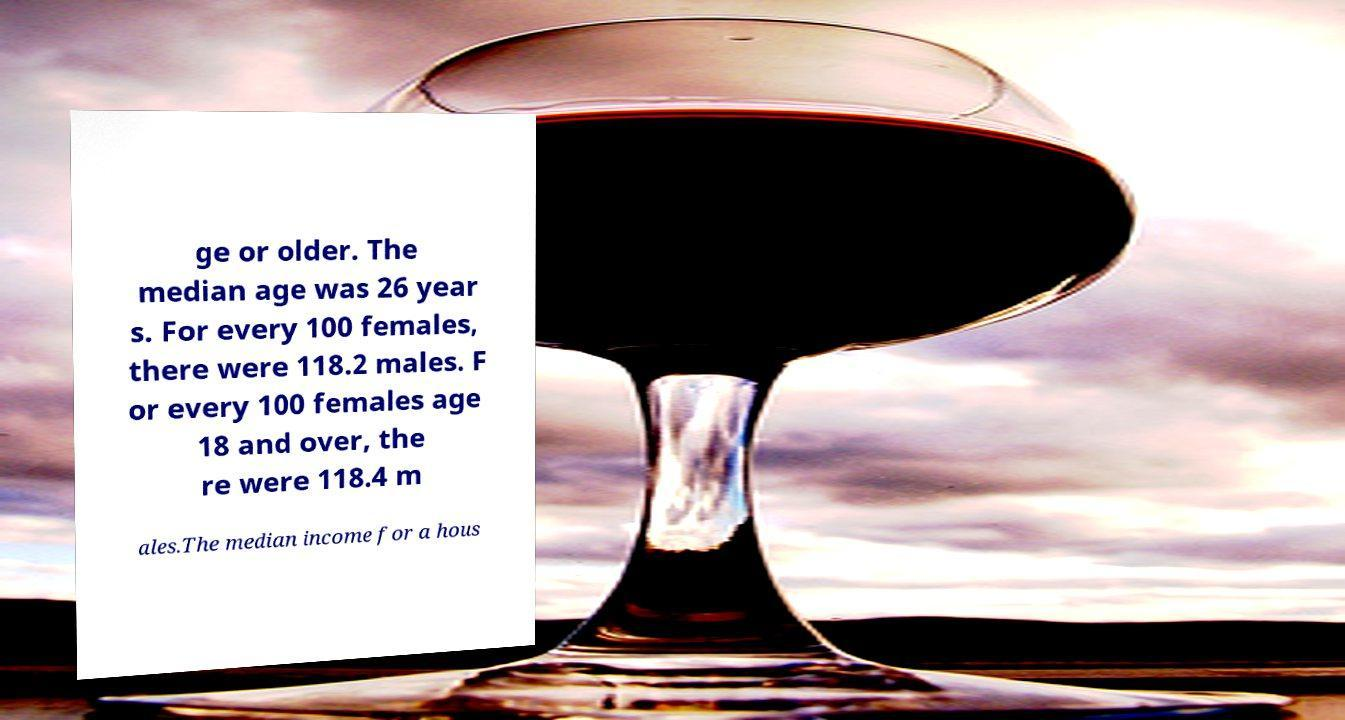Please identify and transcribe the text found in this image. ge or older. The median age was 26 year s. For every 100 females, there were 118.2 males. F or every 100 females age 18 and over, the re were 118.4 m ales.The median income for a hous 